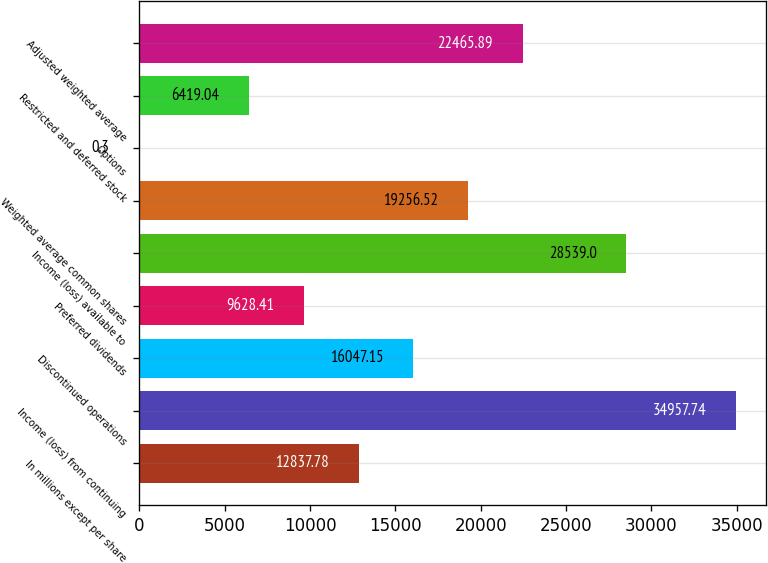Convert chart to OTSL. <chart><loc_0><loc_0><loc_500><loc_500><bar_chart><fcel>In millions except per share<fcel>Income (loss) from continuing<fcel>Discontinued operations<fcel>Preferred dividends<fcel>Income (loss) available to<fcel>Weighted average common shares<fcel>Options<fcel>Restricted and deferred stock<fcel>Adjusted weighted average<nl><fcel>12837.8<fcel>34957.7<fcel>16047.1<fcel>9628.41<fcel>28539<fcel>19256.5<fcel>0.3<fcel>6419.04<fcel>22465.9<nl></chart> 